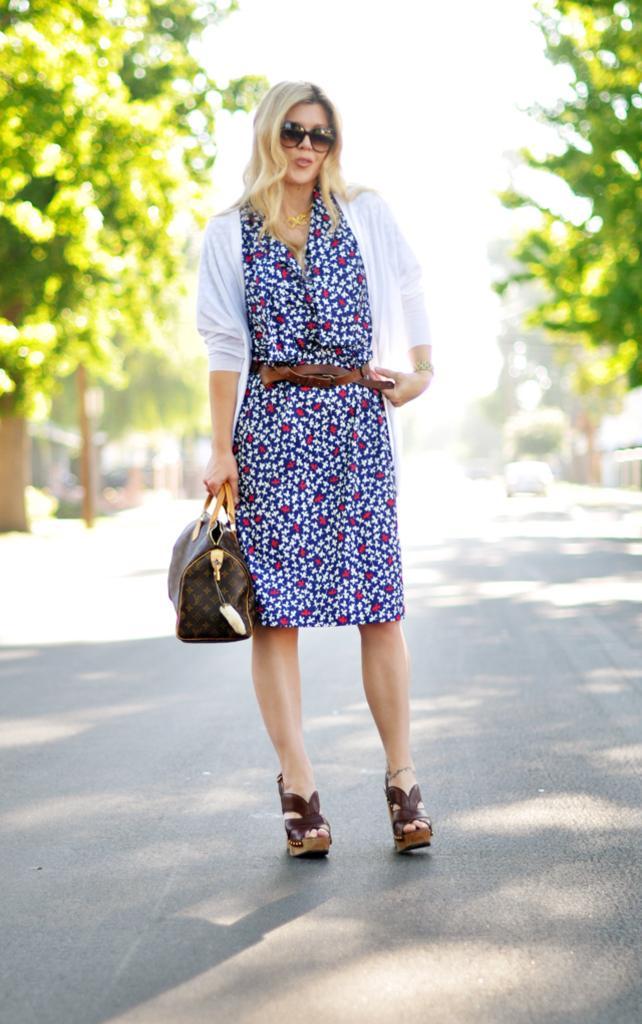Could you give a brief overview of what you see in this image? The woman holding a bag wearing vest with blond hair stood on road with trees on either sides and car in the behind. 